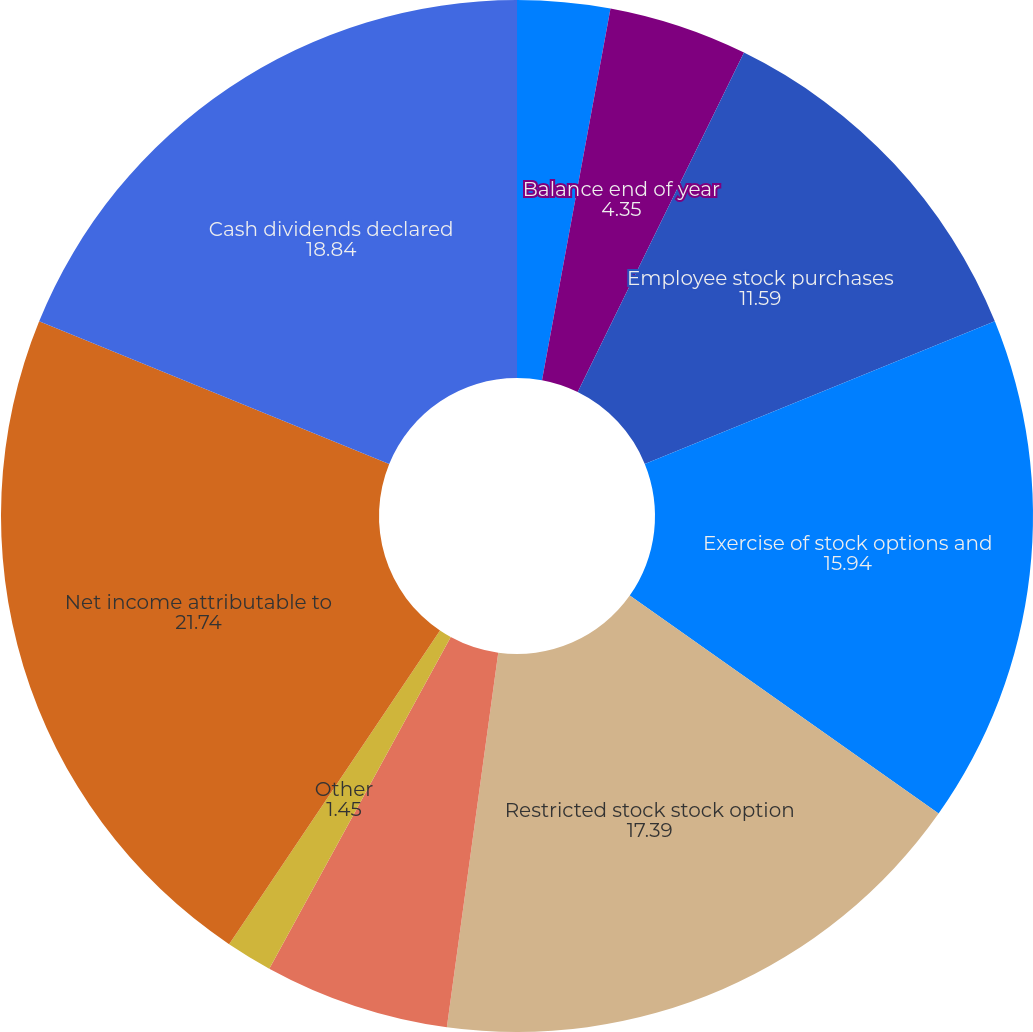<chart> <loc_0><loc_0><loc_500><loc_500><pie_chart><fcel>Balance beginning of year<fcel>Share issuances<fcel>Balance end of year<fcel>Employee stock purchases<fcel>Exercise of stock options and<fcel>Restricted stock stock option<fcel>Excess tax benefit (reduction<fcel>Other<fcel>Net income attributable to<fcel>Cash dividends declared<nl><fcel>2.9%<fcel>0.0%<fcel>4.35%<fcel>11.59%<fcel>15.94%<fcel>17.39%<fcel>5.8%<fcel>1.45%<fcel>21.74%<fcel>18.84%<nl></chart> 